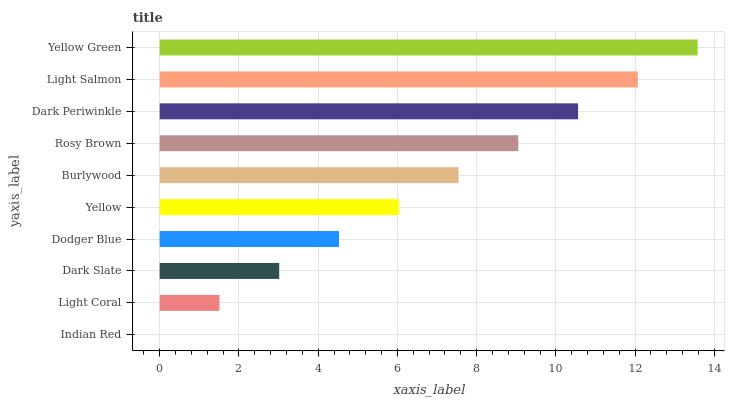Is Indian Red the minimum?
Answer yes or no. Yes. Is Yellow Green the maximum?
Answer yes or no. Yes. Is Light Coral the minimum?
Answer yes or no. No. Is Light Coral the maximum?
Answer yes or no. No. Is Light Coral greater than Indian Red?
Answer yes or no. Yes. Is Indian Red less than Light Coral?
Answer yes or no. Yes. Is Indian Red greater than Light Coral?
Answer yes or no. No. Is Light Coral less than Indian Red?
Answer yes or no. No. Is Burlywood the high median?
Answer yes or no. Yes. Is Yellow the low median?
Answer yes or no. Yes. Is Indian Red the high median?
Answer yes or no. No. Is Yellow Green the low median?
Answer yes or no. No. 